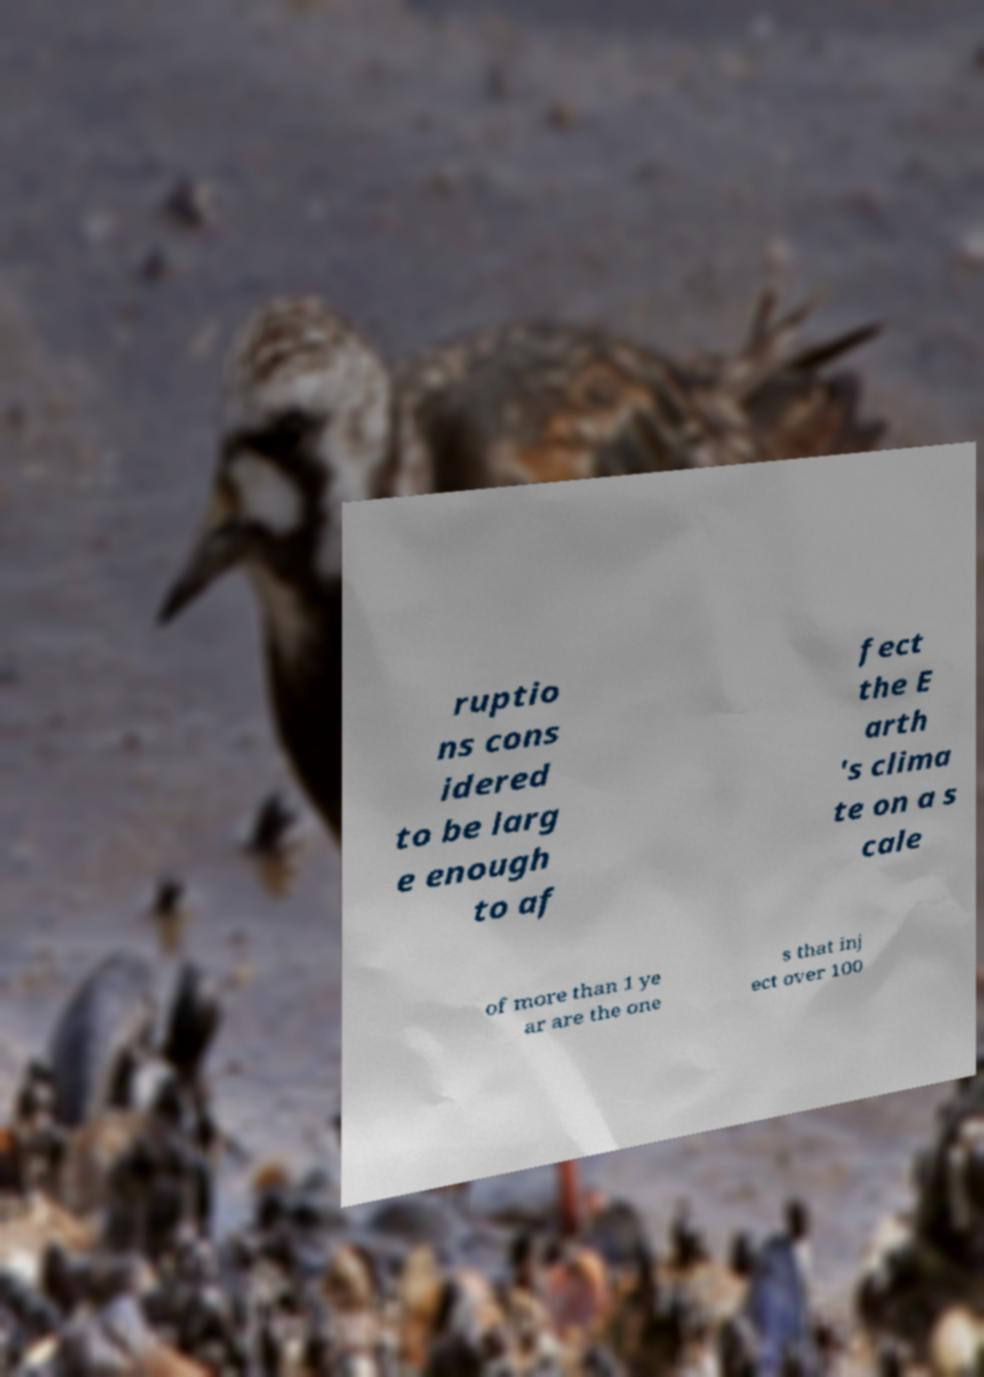Could you assist in decoding the text presented in this image and type it out clearly? ruptio ns cons idered to be larg e enough to af fect the E arth 's clima te on a s cale of more than 1 ye ar are the one s that inj ect over 100 